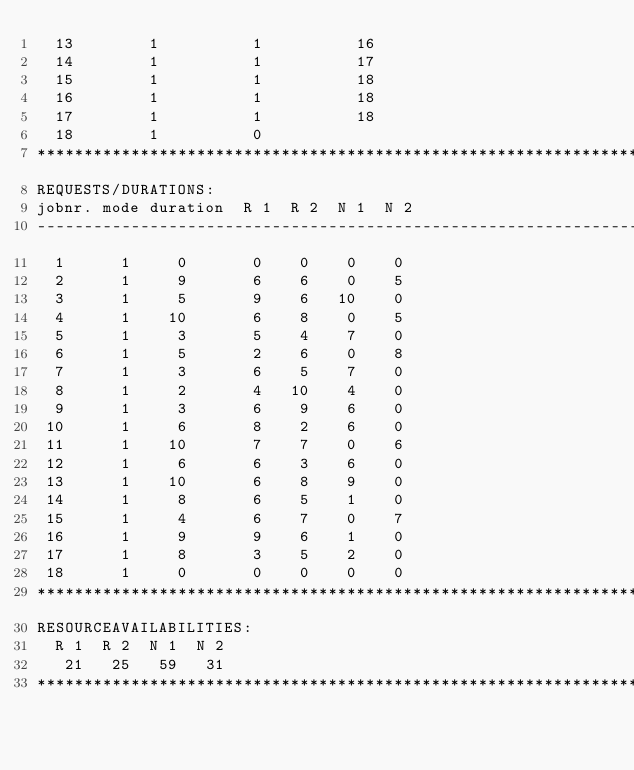Convert code to text. <code><loc_0><loc_0><loc_500><loc_500><_ObjectiveC_>  13        1          1          16
  14        1          1          17
  15        1          1          18
  16        1          1          18
  17        1          1          18
  18        1          0        
************************************************************************
REQUESTS/DURATIONS:
jobnr. mode duration  R 1  R 2  N 1  N 2
------------------------------------------------------------------------
  1      1     0       0    0    0    0
  2      1     9       6    6    0    5
  3      1     5       9    6   10    0
  4      1    10       6    8    0    5
  5      1     3       5    4    7    0
  6      1     5       2    6    0    8
  7      1     3       6    5    7    0
  8      1     2       4   10    4    0
  9      1     3       6    9    6    0
 10      1     6       8    2    6    0
 11      1    10       7    7    0    6
 12      1     6       6    3    6    0
 13      1    10       6    8    9    0
 14      1     8       6    5    1    0
 15      1     4       6    7    0    7
 16      1     9       9    6    1    0
 17      1     8       3    5    2    0
 18      1     0       0    0    0    0
************************************************************************
RESOURCEAVAILABILITIES:
  R 1  R 2  N 1  N 2
   21   25   59   31
************************************************************************
</code> 